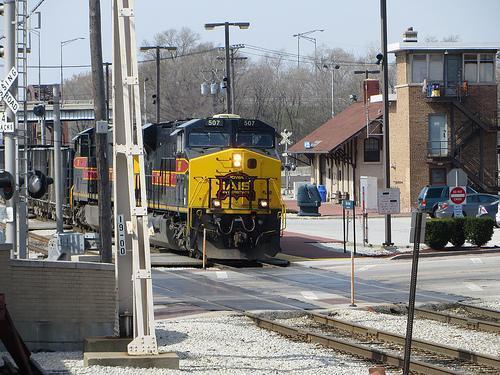How many trains are visible?
Give a very brief answer. 1. 